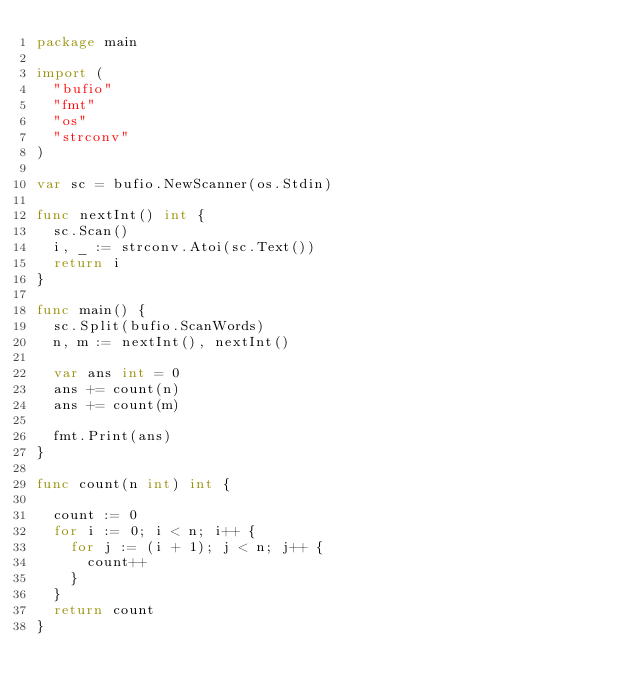<code> <loc_0><loc_0><loc_500><loc_500><_Go_>package main

import (
	"bufio"
	"fmt"
	"os"
	"strconv"
)

var sc = bufio.NewScanner(os.Stdin)

func nextInt() int {
	sc.Scan()
	i, _ := strconv.Atoi(sc.Text())
	return i
}

func main() {
	sc.Split(bufio.ScanWords)
	n, m := nextInt(), nextInt()

	var ans int = 0
	ans += count(n)
	ans += count(m)

	fmt.Print(ans)
}

func count(n int) int {

	count := 0
	for i := 0; i < n; i++ {
		for j := (i + 1); j < n; j++ {
			count++
		}
	}
	return count
}
</code> 